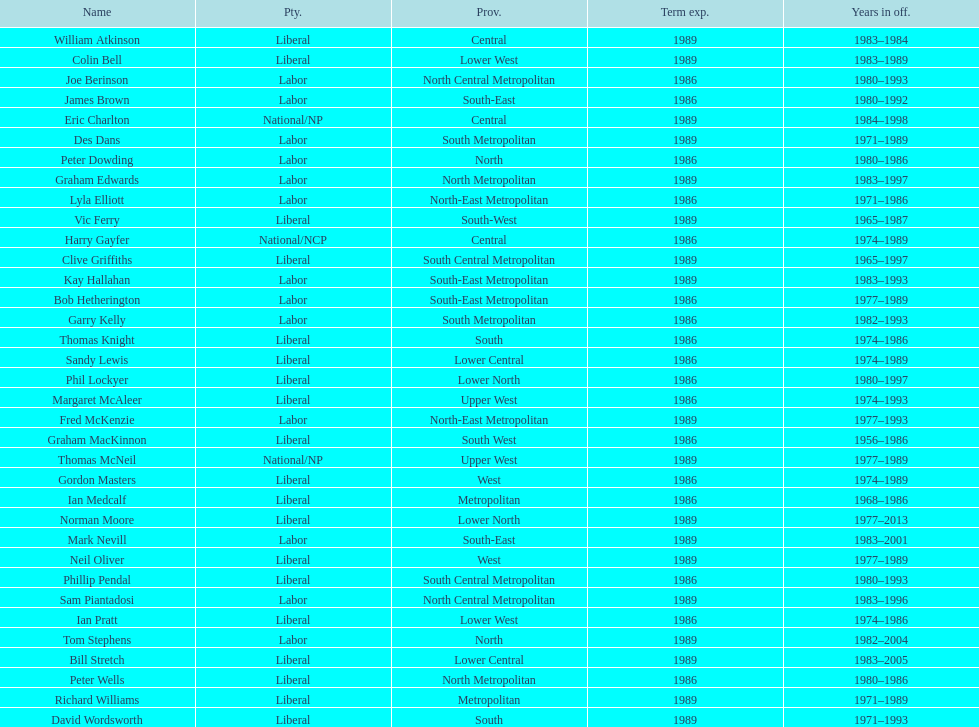How many members were party of lower west province? 2. 